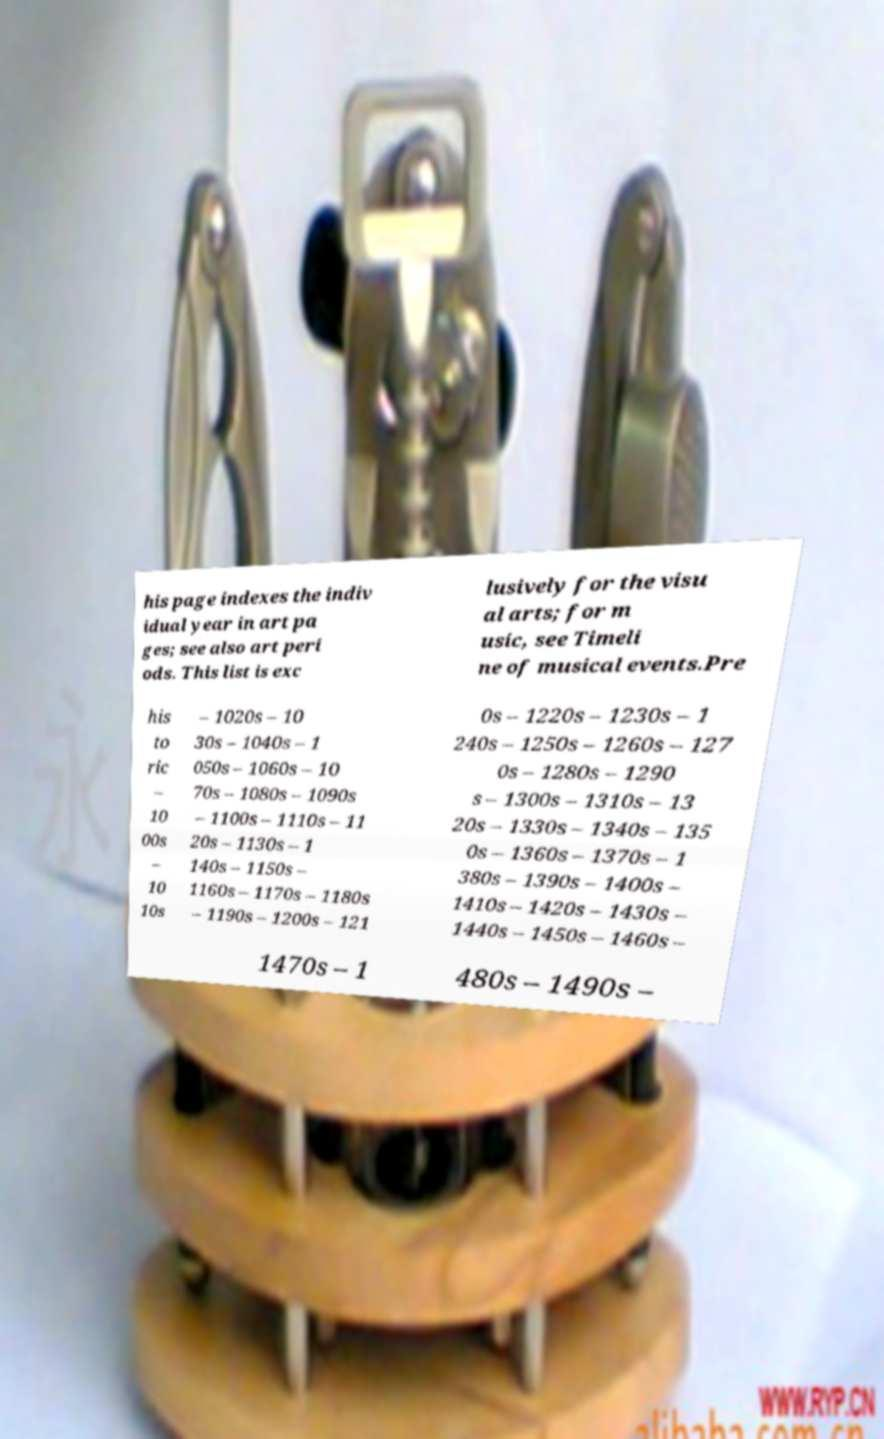Can you read and provide the text displayed in the image?This photo seems to have some interesting text. Can you extract and type it out for me? his page indexes the indiv idual year in art pa ges; see also art peri ods. This list is exc lusively for the visu al arts; for m usic, see Timeli ne of musical events.Pre his to ric – 10 00s – 10 10s – 1020s – 10 30s – 1040s – 1 050s – 1060s – 10 70s – 1080s – 1090s – 1100s – 1110s – 11 20s – 1130s – 1 140s – 1150s – 1160s – 1170s – 1180s – 1190s – 1200s – 121 0s – 1220s – 1230s – 1 240s – 1250s – 1260s – 127 0s – 1280s – 1290 s – 1300s – 1310s – 13 20s – 1330s – 1340s – 135 0s – 1360s – 1370s – 1 380s – 1390s – 1400s – 1410s – 1420s – 1430s – 1440s – 1450s – 1460s – 1470s – 1 480s – 1490s – 